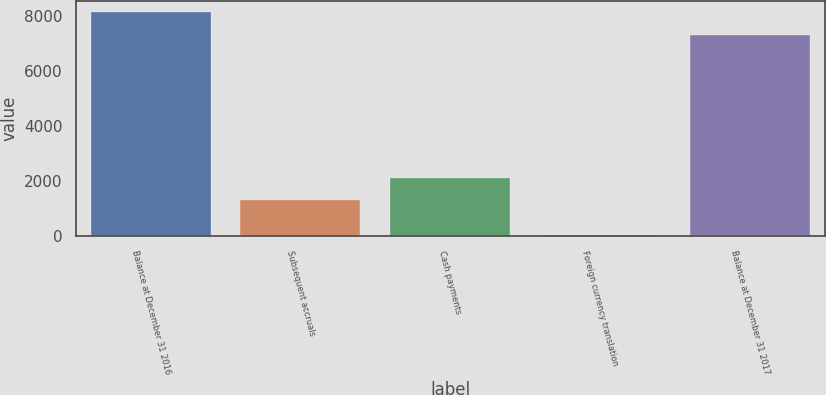Convert chart to OTSL. <chart><loc_0><loc_0><loc_500><loc_500><bar_chart><fcel>Balance at December 31 2016<fcel>Subsequent accruals<fcel>Cash payments<fcel>Foreign currency translation<fcel>Balance at December 31 2017<nl><fcel>8135<fcel>1314<fcel>2121.8<fcel>57<fcel>7296<nl></chart> 